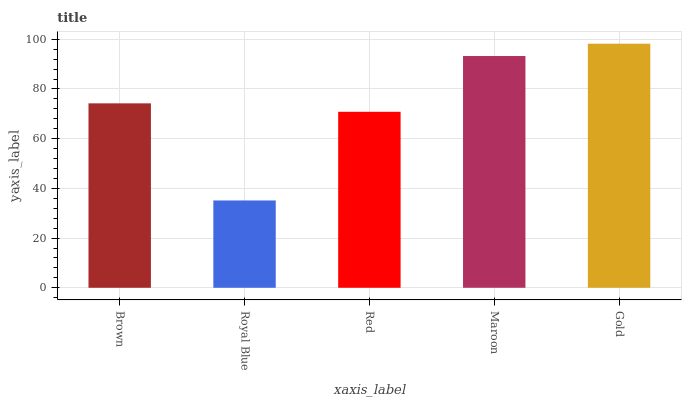Is Royal Blue the minimum?
Answer yes or no. Yes. Is Gold the maximum?
Answer yes or no. Yes. Is Red the minimum?
Answer yes or no. No. Is Red the maximum?
Answer yes or no. No. Is Red greater than Royal Blue?
Answer yes or no. Yes. Is Royal Blue less than Red?
Answer yes or no. Yes. Is Royal Blue greater than Red?
Answer yes or no. No. Is Red less than Royal Blue?
Answer yes or no. No. Is Brown the high median?
Answer yes or no. Yes. Is Brown the low median?
Answer yes or no. Yes. Is Royal Blue the high median?
Answer yes or no. No. Is Red the low median?
Answer yes or no. No. 